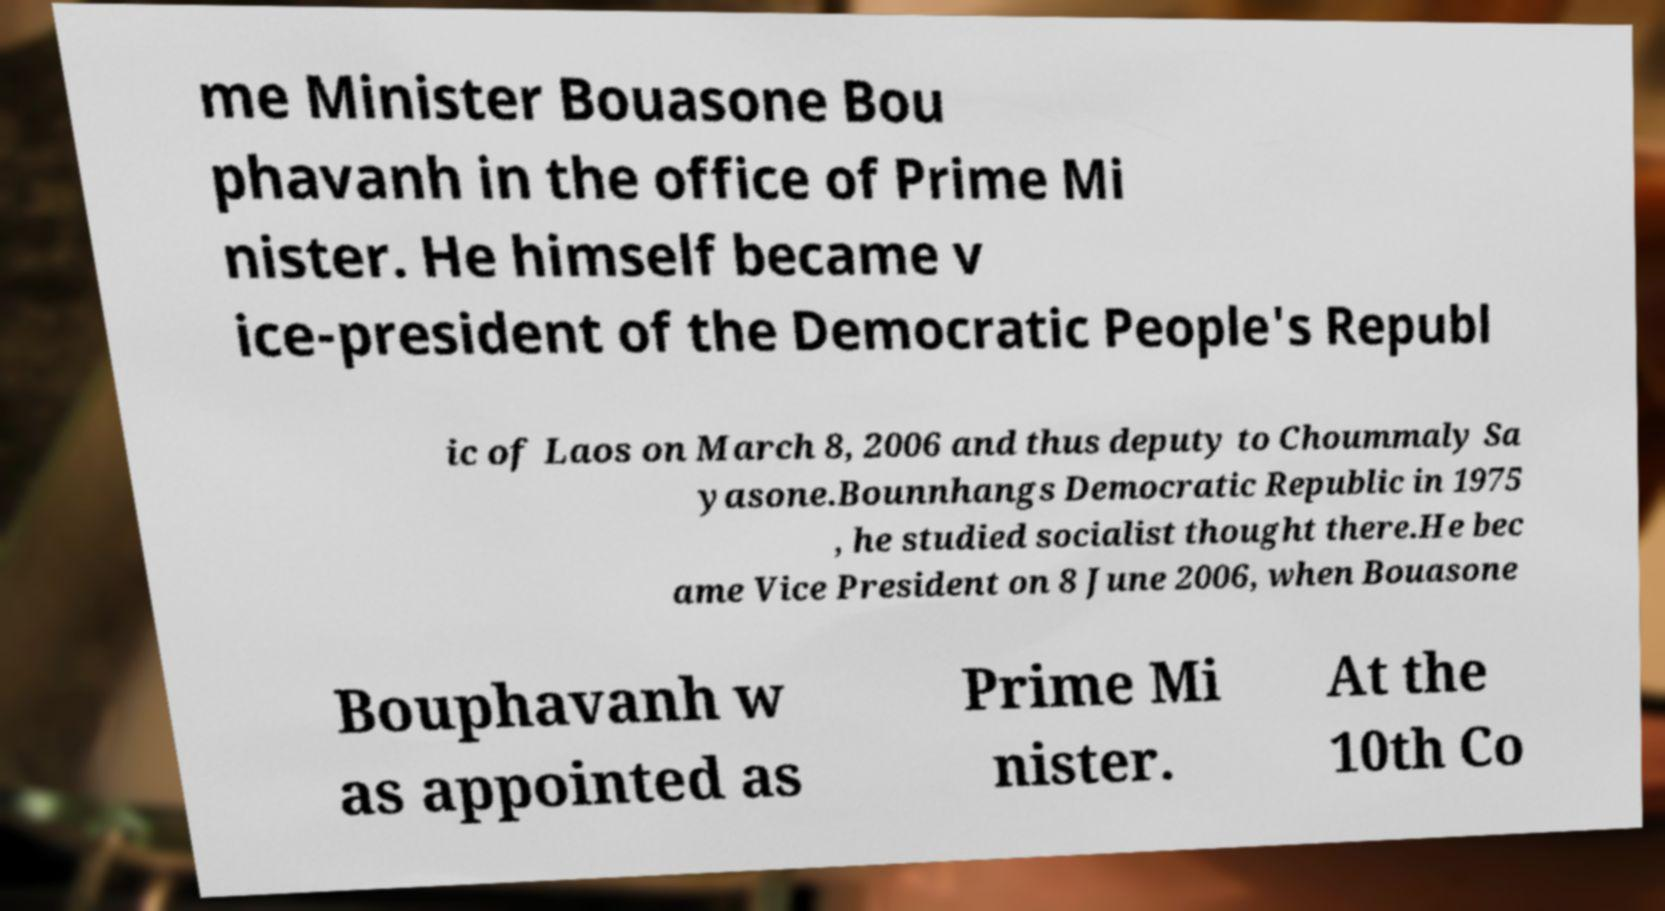There's text embedded in this image that I need extracted. Can you transcribe it verbatim? me Minister Bouasone Bou phavanh in the office of Prime Mi nister. He himself became v ice-president of the Democratic People's Republ ic of Laos on March 8, 2006 and thus deputy to Choummaly Sa yasone.Bounnhangs Democratic Republic in 1975 , he studied socialist thought there.He bec ame Vice President on 8 June 2006, when Bouasone Bouphavanh w as appointed as Prime Mi nister. At the 10th Co 